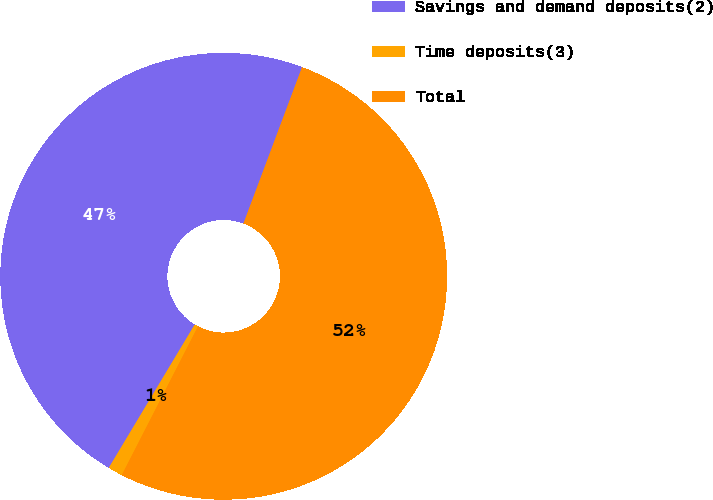<chart> <loc_0><loc_0><loc_500><loc_500><pie_chart><fcel>Savings and demand deposits(2)<fcel>Time deposits(3)<fcel>Total<nl><fcel>47.11%<fcel>1.06%<fcel>51.83%<nl></chart> 